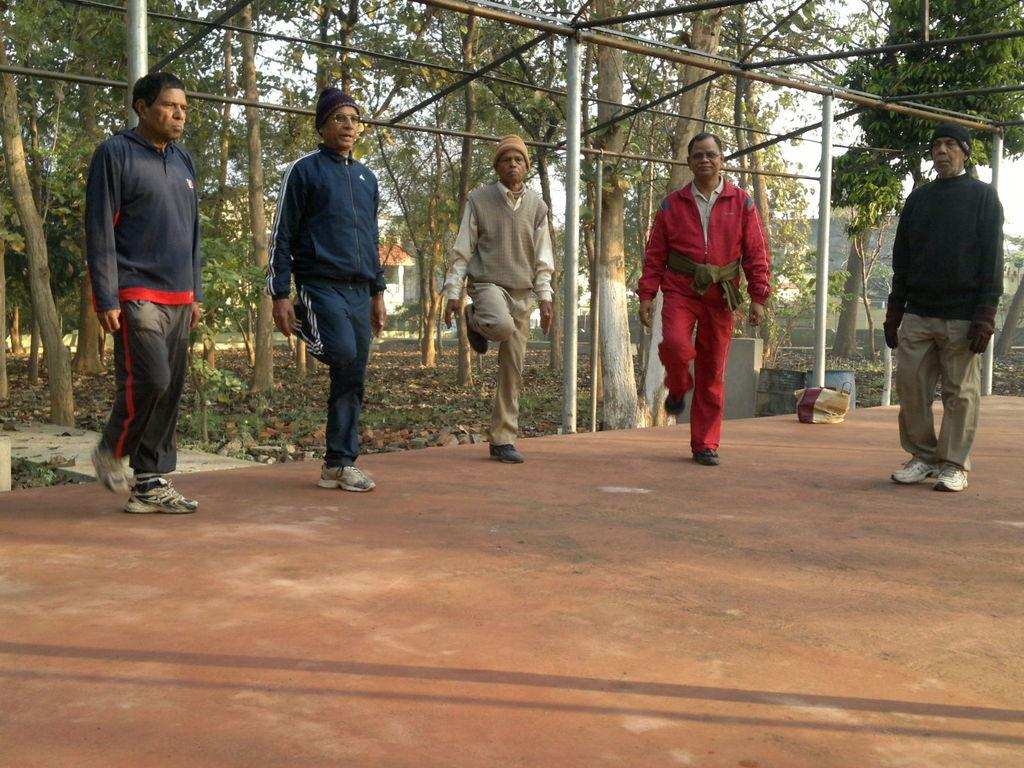How many people are standing on the path in the image? There are five persons standing on the path in the image. What can be seen in the background of the image? In the background, there are iron rods, plants, grass, trees, buildings, and the sky. Can you describe the natural elements visible in the background? The natural elements in the background include plants, grass, and trees. What type of juice is being served to the persons in the image? There is no juice present in the image; it features five persons standing on a path with various background elements. 